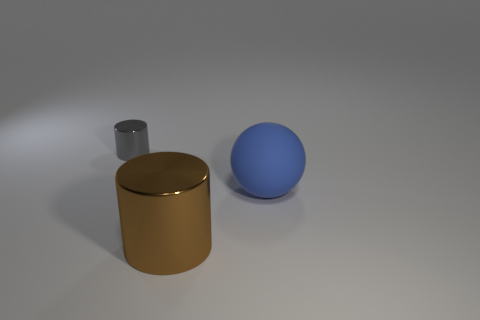How many other objects are the same shape as the blue thing?
Provide a succinct answer. 0. There is a metal cylinder on the left side of the big thing that is to the left of the blue sphere; what size is it?
Offer a terse response. Small. Is there a gray metal object?
Offer a very short reply. Yes. There is a cylinder right of the small cylinder; how many small metallic things are left of it?
Offer a very short reply. 1. There is a thing left of the large brown cylinder; what is its shape?
Give a very brief answer. Cylinder. There is a cylinder on the right side of the metal cylinder that is on the left side of the big thing in front of the ball; what is it made of?
Provide a short and direct response. Metal. What number of other things are there of the same size as the matte sphere?
Ensure brevity in your answer.  1. There is a gray object that is the same shape as the brown object; what is it made of?
Offer a terse response. Metal. The sphere has what color?
Offer a terse response. Blue. What color is the cylinder in front of the metallic thing behind the large cylinder?
Provide a succinct answer. Brown. 